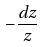<formula> <loc_0><loc_0><loc_500><loc_500>- \frac { d z } { z }</formula> 